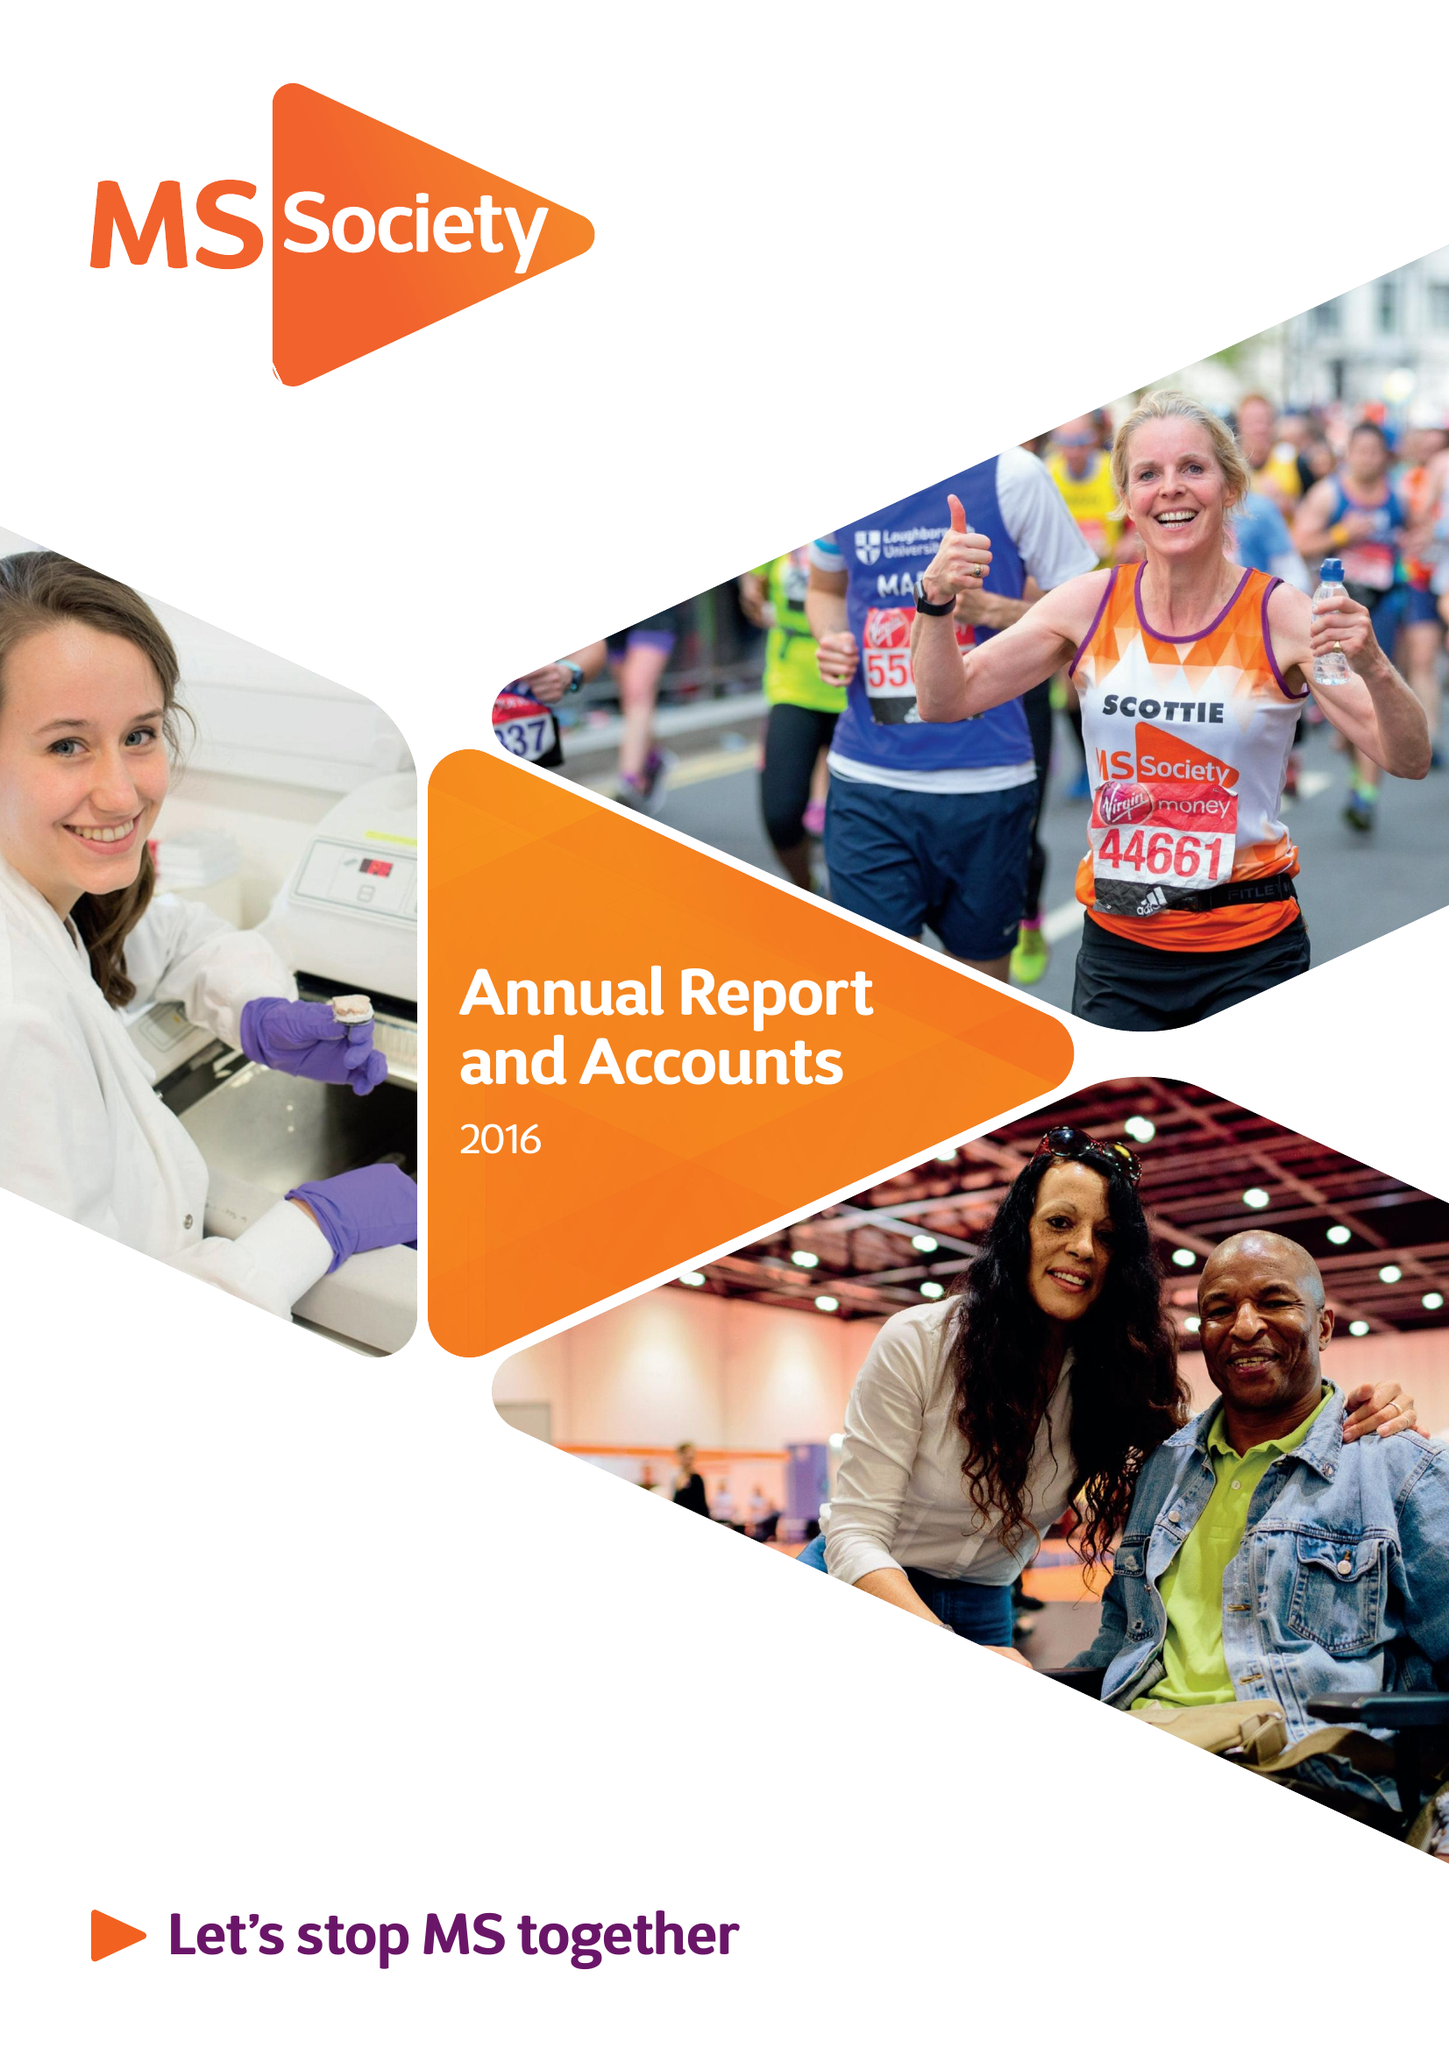What is the value for the charity_number?
Answer the question using a single word or phrase. 1139257 